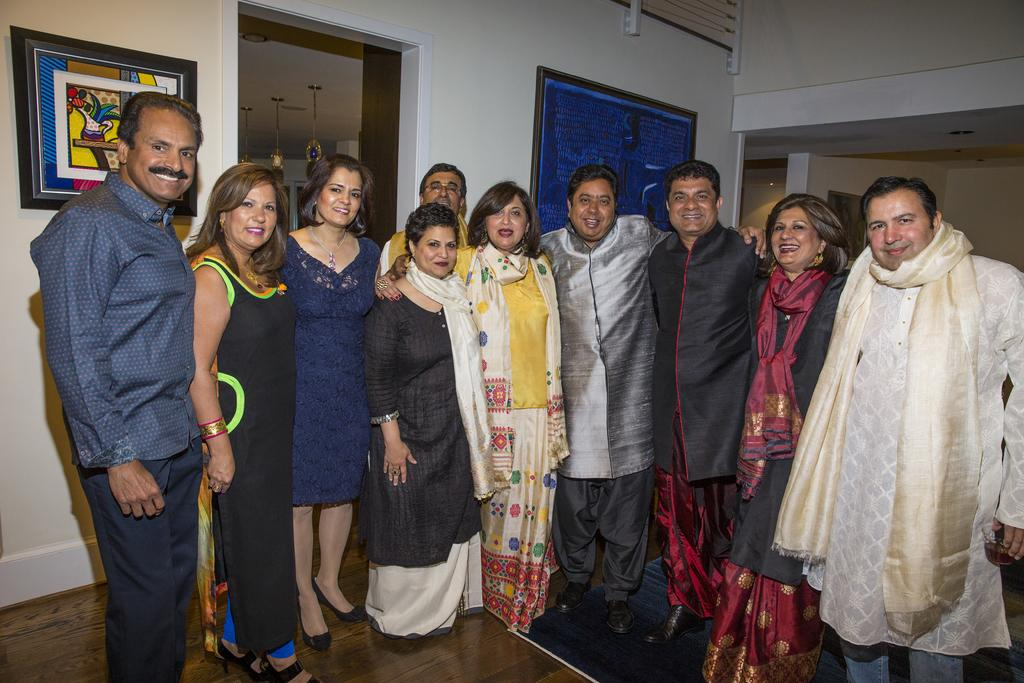What types of people are in the image? There are men and women in the image. What are the people in the image doing? The people are standing and smiling. What are the people wearing in the image? They are wearing traditional dresses. What can be seen in the background of the image? There is a white color wall in the background. What is attached to the wall in the image? Frames are attached to the wall. What type of lumber is being used to build the house in the image? There is no house or lumber present in the image; it features people standing and smiling while wearing traditional dresses. How does the journey of the people in the image progress? The image does not depict a journey or any movement; it shows people standing in a stationary position. 